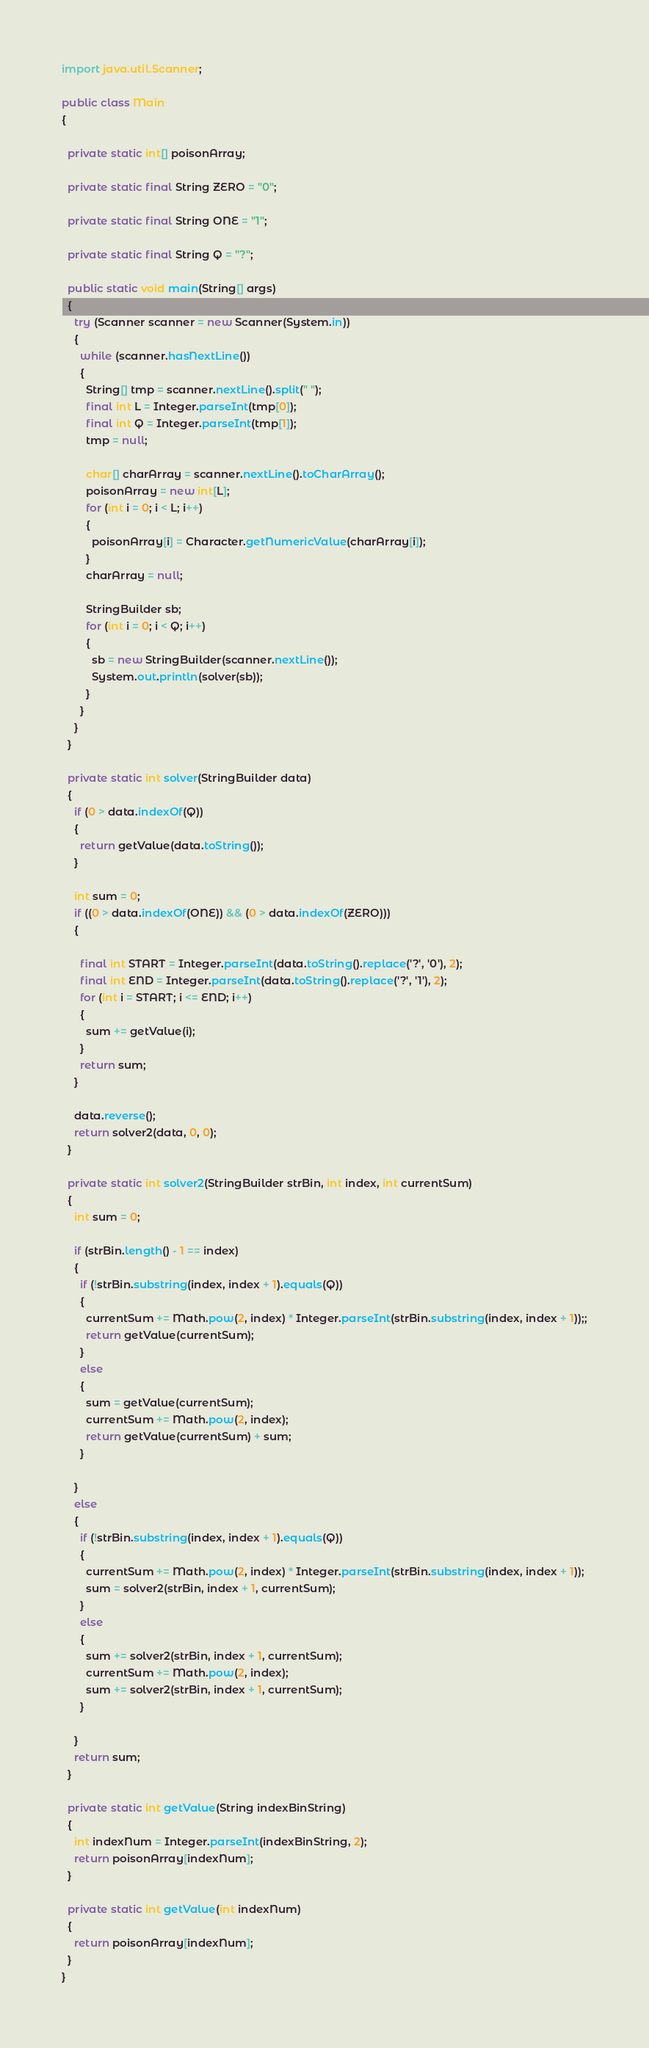<code> <loc_0><loc_0><loc_500><loc_500><_Java_>import java.util.Scanner;

public class Main
{

  private static int[] poisonArray;

  private static final String ZERO = "0";

  private static final String ONE = "1";

  private static final String Q = "?";

  public static void main(String[] args)
  {
    try (Scanner scanner = new Scanner(System.in))
    {
      while (scanner.hasNextLine())
      {
        String[] tmp = scanner.nextLine().split(" ");
        final int L = Integer.parseInt(tmp[0]);
        final int Q = Integer.parseInt(tmp[1]);
        tmp = null;

        char[] charArray = scanner.nextLine().toCharArray();
        poisonArray = new int[L];
        for (int i = 0; i < L; i++)
        {
          poisonArray[i] = Character.getNumericValue(charArray[i]);
        }
        charArray = null;

        StringBuilder sb;
        for (int i = 0; i < Q; i++)
        {
          sb = new StringBuilder(scanner.nextLine());
          System.out.println(solver(sb));
        }
      }
    }
  }

  private static int solver(StringBuilder data)
  {
    if (0 > data.indexOf(Q))
    {
      return getValue(data.toString());
    }

    int sum = 0;
    if ((0 > data.indexOf(ONE)) && (0 > data.indexOf(ZERO)))
    {

      final int START = Integer.parseInt(data.toString().replace('?', '0'), 2);
      final int END = Integer.parseInt(data.toString().replace('?', '1'), 2);
      for (int i = START; i <= END; i++)
      {
        sum += getValue(i);
      }
      return sum;
    }

    data.reverse();
    return solver2(data, 0, 0);
  }

  private static int solver2(StringBuilder strBin, int index, int currentSum)
  {
    int sum = 0;

    if (strBin.length() - 1 == index)
    {
      if (!strBin.substring(index, index + 1).equals(Q))
      {
        currentSum += Math.pow(2, index) * Integer.parseInt(strBin.substring(index, index + 1));;
        return getValue(currentSum);
      }
      else
      {
        sum = getValue(currentSum);
        currentSum += Math.pow(2, index);
        return getValue(currentSum) + sum;
      }

    }
    else
    {
      if (!strBin.substring(index, index + 1).equals(Q))
      {
        currentSum += Math.pow(2, index) * Integer.parseInt(strBin.substring(index, index + 1));
        sum = solver2(strBin, index + 1, currentSum);
      }
      else
      {
        sum += solver2(strBin, index + 1, currentSum);
        currentSum += Math.pow(2, index);
        sum += solver2(strBin, index + 1, currentSum);
      }

    }
    return sum;
  }

  private static int getValue(String indexBinString)
  {
    int indexNum = Integer.parseInt(indexBinString, 2);
    return poisonArray[indexNum];
  }

  private static int getValue(int indexNum)
  {
    return poisonArray[indexNum];
  }
}

</code> 